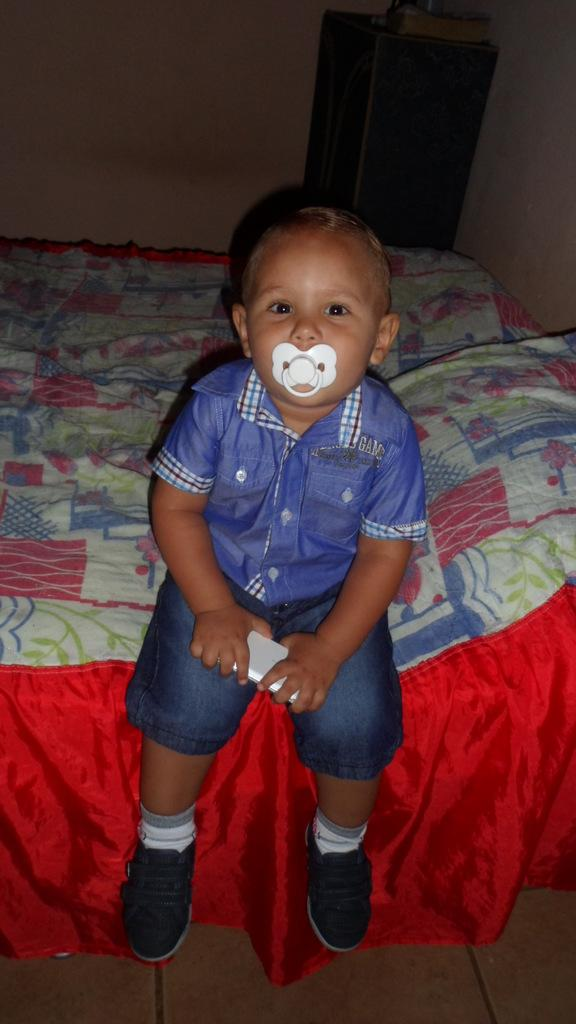Who is in the image? There is a boy in the image. What is the boy wearing? The boy is wearing a blue shirt. Where is the boy sitting? The boy is sitting on the bed. What can be seen on the bed? There are pillows on the bed. What is the boy holding in his hand? The boy is holding an object in his hand. What is located beside the bed? There is a table beside the bed. What is on the table? There is a book on the table. What type of ticket is the boy holding in his hand? The boy is not holding a ticket in his hand; he is holding an unspecified object. What is the boy discussing with someone in the image? There is no indication of a discussion or another person in the image. 